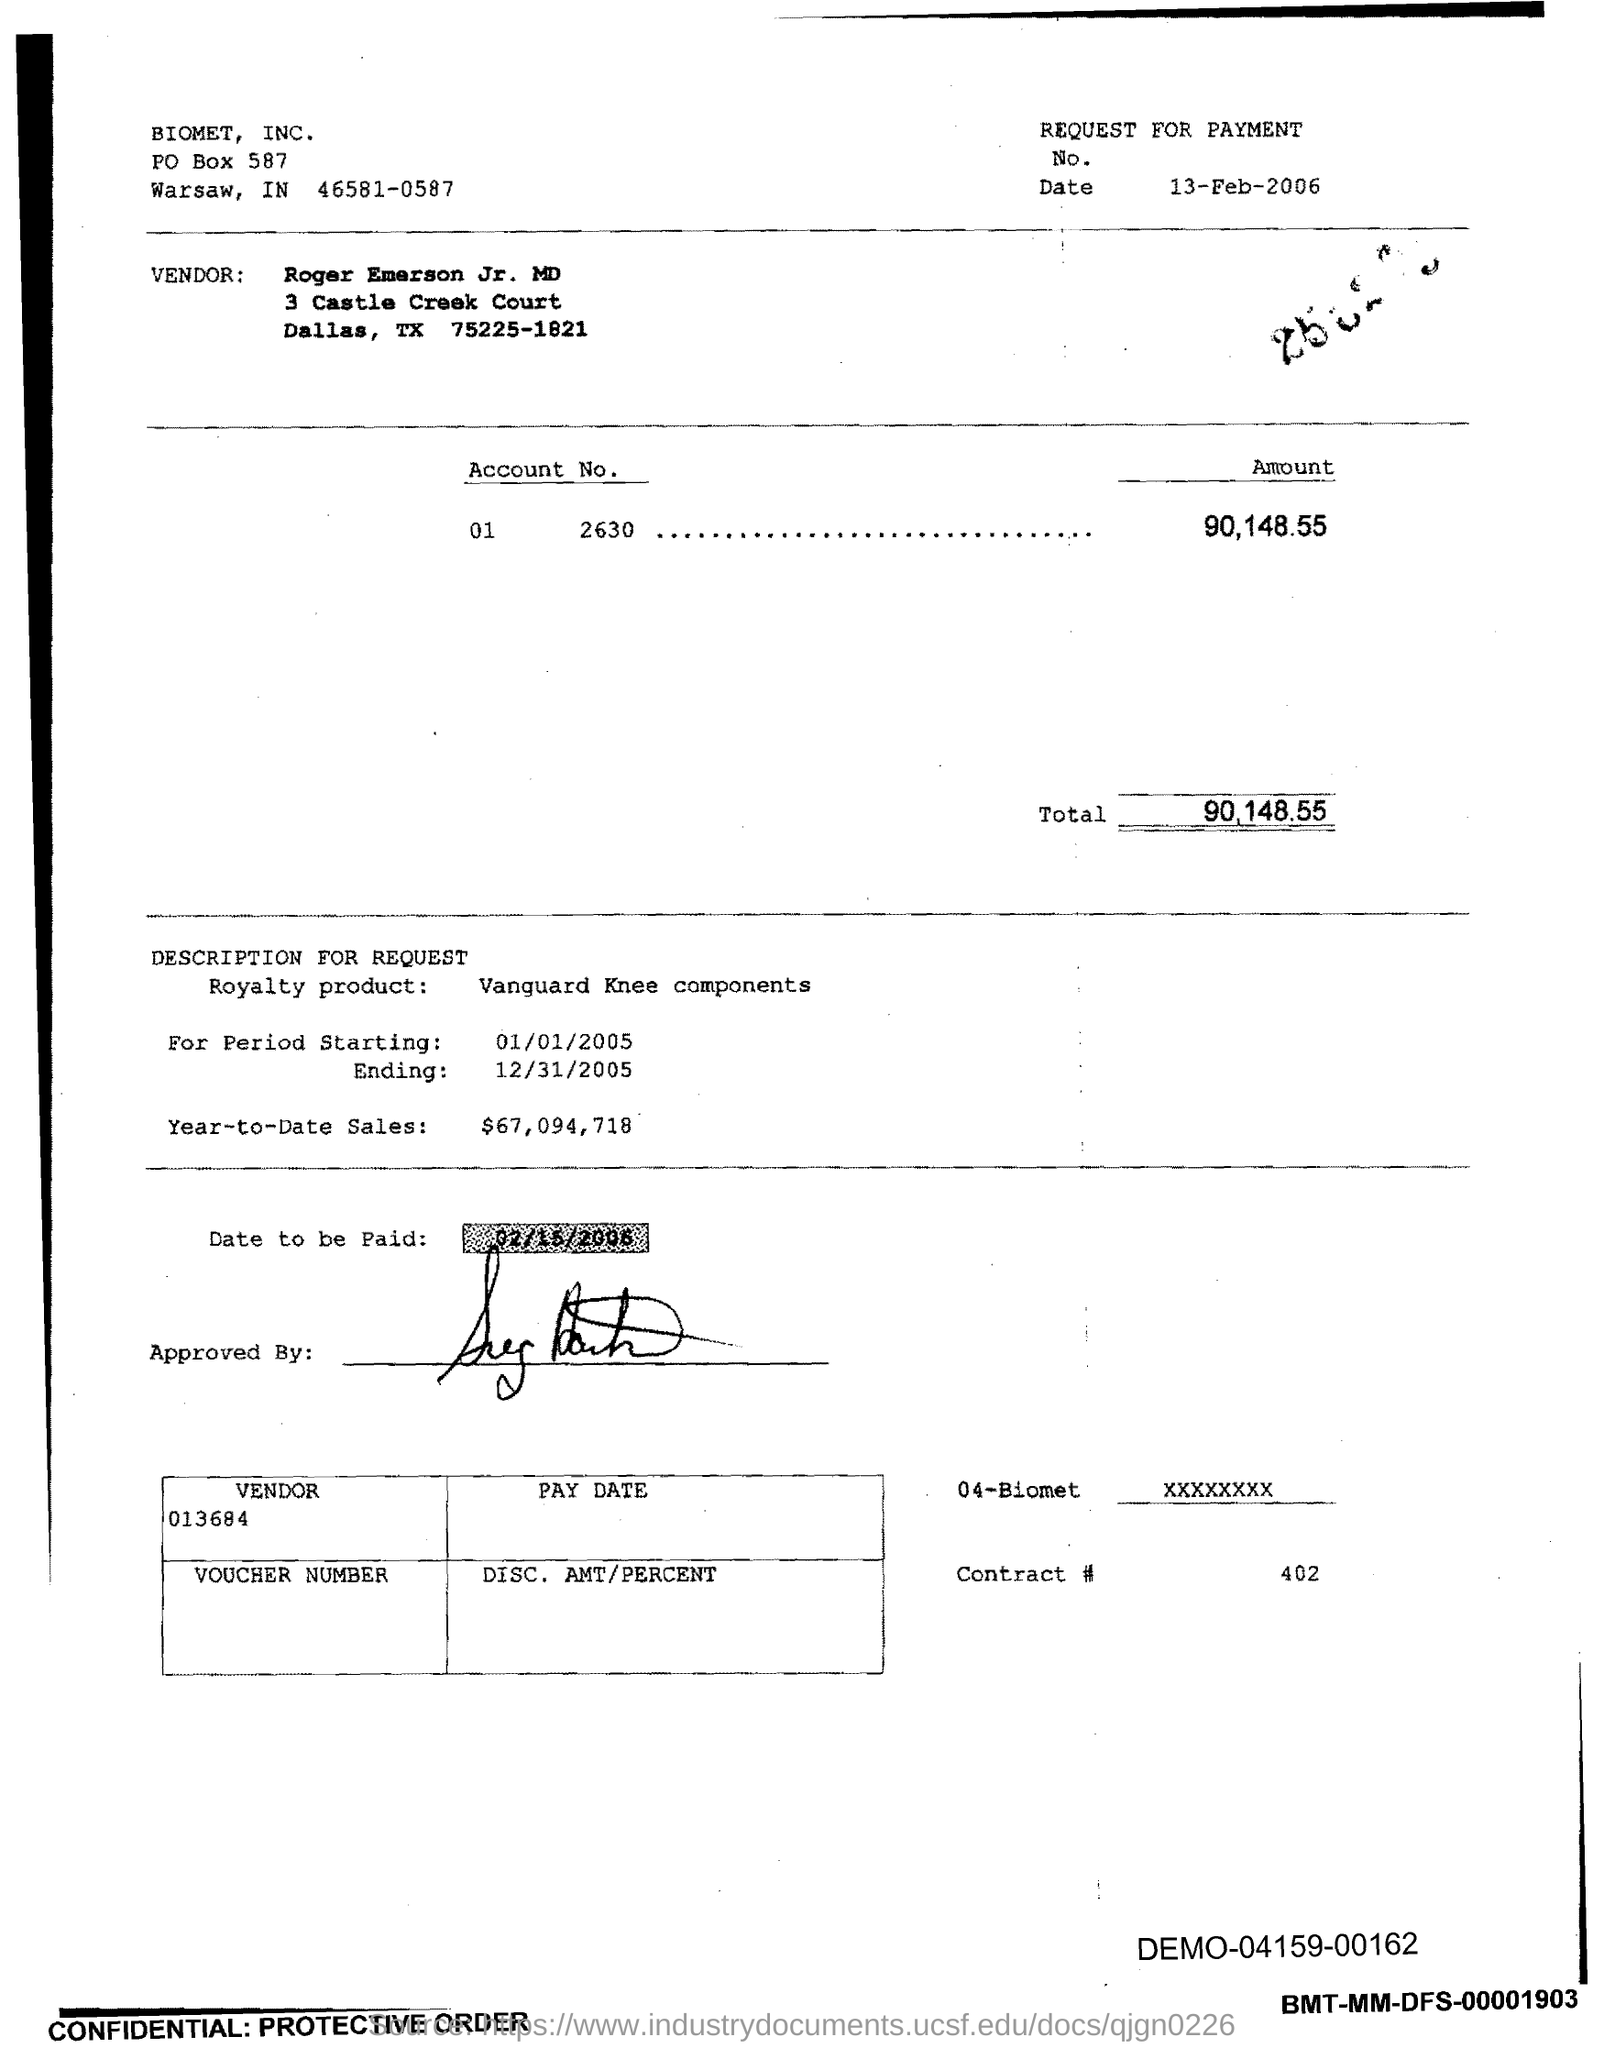Point out several critical features in this image. The vendor ID is 013684. On February 13th, 2006, the request for payment was raised. The vendor is Roger Emerson Jr., the MD. The contract number is 402, as declared. 